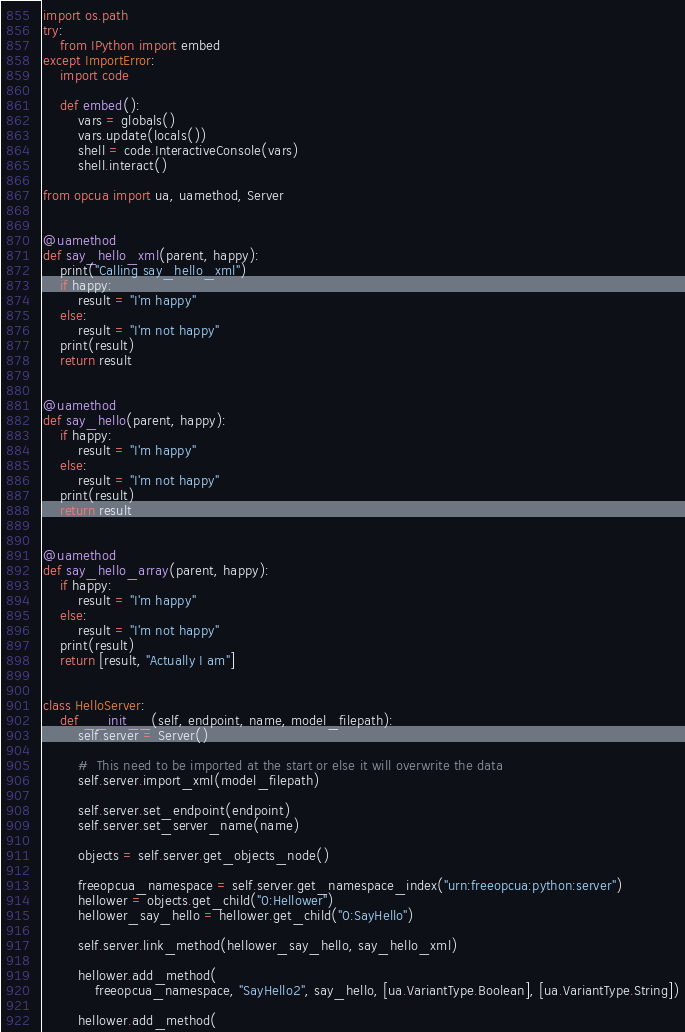<code> <loc_0><loc_0><loc_500><loc_500><_Python_>import os.path
try:
    from IPython import embed
except ImportError:
    import code

    def embed():
        vars = globals()
        vars.update(locals())
        shell = code.InteractiveConsole(vars)
        shell.interact()

from opcua import ua, uamethod, Server


@uamethod
def say_hello_xml(parent, happy):
    print("Calling say_hello_xml")
    if happy:
        result = "I'm happy"
    else:
        result = "I'm not happy"
    print(result)
    return result


@uamethod
def say_hello(parent, happy):
    if happy:
        result = "I'm happy"
    else:
        result = "I'm not happy"
    print(result)
    return result


@uamethod
def say_hello_array(parent, happy):
    if happy:
        result = "I'm happy"
    else:
        result = "I'm not happy"
    print(result)
    return [result, "Actually I am"]


class HelloServer:
    def __init__(self, endpoint, name, model_filepath):
        self.server = Server()

        #  This need to be imported at the start or else it will overwrite the data
        self.server.import_xml(model_filepath)

        self.server.set_endpoint(endpoint)
        self.server.set_server_name(name)

        objects = self.server.get_objects_node()

        freeopcua_namespace = self.server.get_namespace_index("urn:freeopcua:python:server")
        hellower = objects.get_child("0:Hellower")
        hellower_say_hello = hellower.get_child("0:SayHello")

        self.server.link_method(hellower_say_hello, say_hello_xml)

        hellower.add_method(
            freeopcua_namespace, "SayHello2", say_hello, [ua.VariantType.Boolean], [ua.VariantType.String])

        hellower.add_method(</code> 